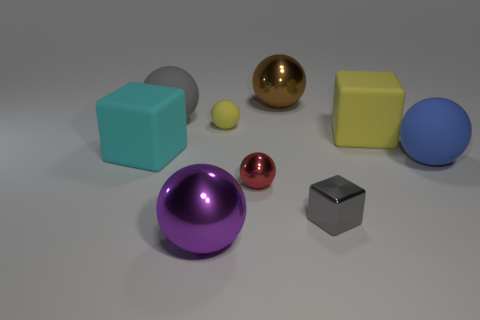There is a thing that is the same color as the tiny metallic block; what is its material?
Keep it short and to the point. Rubber. How many big rubber things have the same color as the small rubber thing?
Give a very brief answer. 1. What is the size of the gray object in front of the large rubber block that is to the right of the big purple ball?
Provide a succinct answer. Small. How many things are either spheres on the right side of the big purple thing or small things?
Give a very brief answer. 5. Is there a yellow matte block that has the same size as the red metal sphere?
Keep it short and to the point. No. There is a big matte ball behind the blue ball; is there a small metal sphere that is to the left of it?
Your response must be concise. No. How many balls are large blue things or large rubber objects?
Offer a terse response. 2. Is there a large blue thing that has the same shape as the large purple metal object?
Offer a very short reply. Yes. What is the shape of the gray metallic object?
Make the answer very short. Cube. How many things are small rubber spheres or tiny gray things?
Keep it short and to the point. 2. 